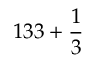<formula> <loc_0><loc_0><loc_500><loc_500>1 3 3 + { \frac { 1 } { 3 } }</formula> 